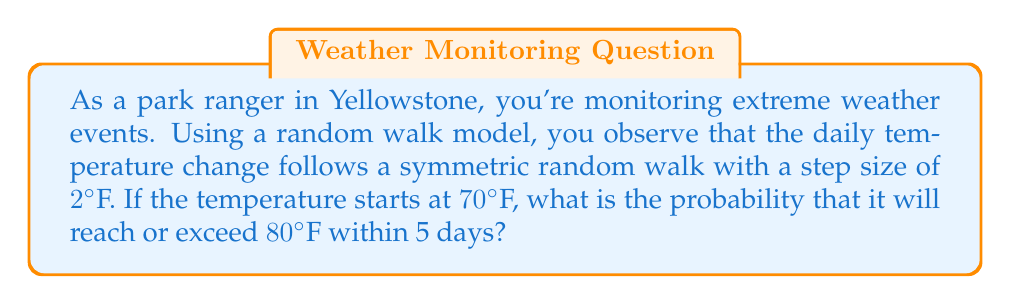Give your solution to this math problem. Let's approach this step-by-step:

1) This scenario can be modeled as a one-dimensional random walk. We need to calculate the probability of reaching a specific point (80°F or higher) within a given number of steps (5 days).

2) The distance to reach: 
   $80°F - 70°F = 10°F$

3) Number of steps needed to reach or exceed 80°F:
   $\lceil 10°F / 2°F \rceil = 5$ steps upward

4) Total possible steps in 5 days: 5

5) We need to calculate the probability of getting 5 or more upward steps out of 5 total steps.

6) This follows a binomial distribution with parameters:
   $n = 5$ (total steps)
   $p = 0.5$ (probability of an upward step)

7) The probability is:

   $$P(X \geq 5) = \binom{5}{5} (0.5)^5 = (0.5)^5 = \frac{1}{32}$$

8) Therefore, the probability of reaching or exceeding 80°F within 5 days is $\frac{1}{32}$ or approximately 0.03125.
Answer: $\frac{1}{32}$ 